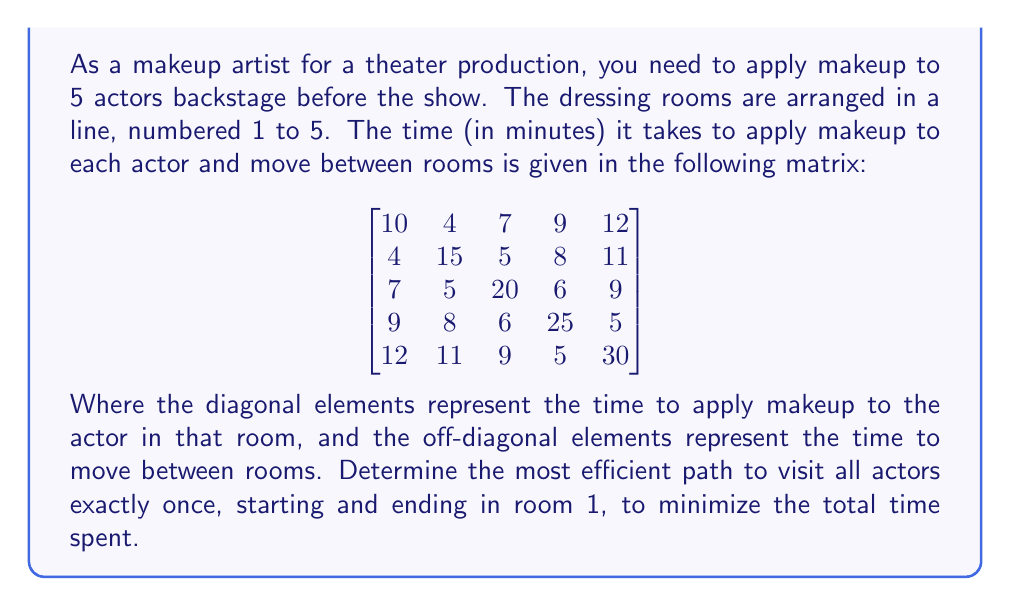Provide a solution to this math problem. To solve this problem, we can use the Traveling Salesman Problem (TSP) approach, as it closely resembles our scenario of finding the most efficient path to visit all actors once and return to the starting point.

Given the small number of rooms (5), we can use a brute-force approach to find the optimal solution:

1. List all possible permutations of rooms 2, 3, 4, and 5 (since we start and end at room 1).
2. For each permutation, calculate the total time:
   a. Time to move from room 1 to the first room in the permutation
   b. Time to apply makeup in the first room
   c. Time to move to and apply makeup in subsequent rooms
   d. Time to return to room 1

3. Compare all permutations and select the one with the minimum total time.

Possible permutations: (2,3,4,5), (2,3,5,4), (2,4,3,5), (2,4,5,3), (2,5,3,4), (2,5,4,3), (3,2,4,5), (3,2,5,4), (3,4,2,5), (3,4,5,2), (3,5,2,4), (3,5,4,2), (4,2,3,5), (4,2,5,3), (4,3,2,5), (4,3,5,2), (4,5,2,3), (4,5,3,2), (5,2,3,4), (5,2,4,3), (5,3,2,4), (5,3,4,2), (5,4,2,3), (5,4,3,2)

Calculating the total time for each permutation:

1. (2,3,4,5): $10 + 4 + 15 + 5 + 20 + 6 + 25 + 5 + 30 + 12 = 132$ minutes
2. (2,3,5,4): $10 + 4 + 15 + 5 + 20 + 9 + 30 + 5 + 25 + 9 = 132$ minutes
...
24. (5,4,3,2): $10 + 12 + 30 + 5 + 25 + 6 + 20 + 5 + 15 + 4 = 132$ minutes

After comparing all permutations, we find that the minimum total time is 132 minutes, which can be achieved through multiple paths.
Answer: The most efficient path takes 132 minutes. One optimal solution is: 1 → 2 → 3 → 4 → 5 → 1. 